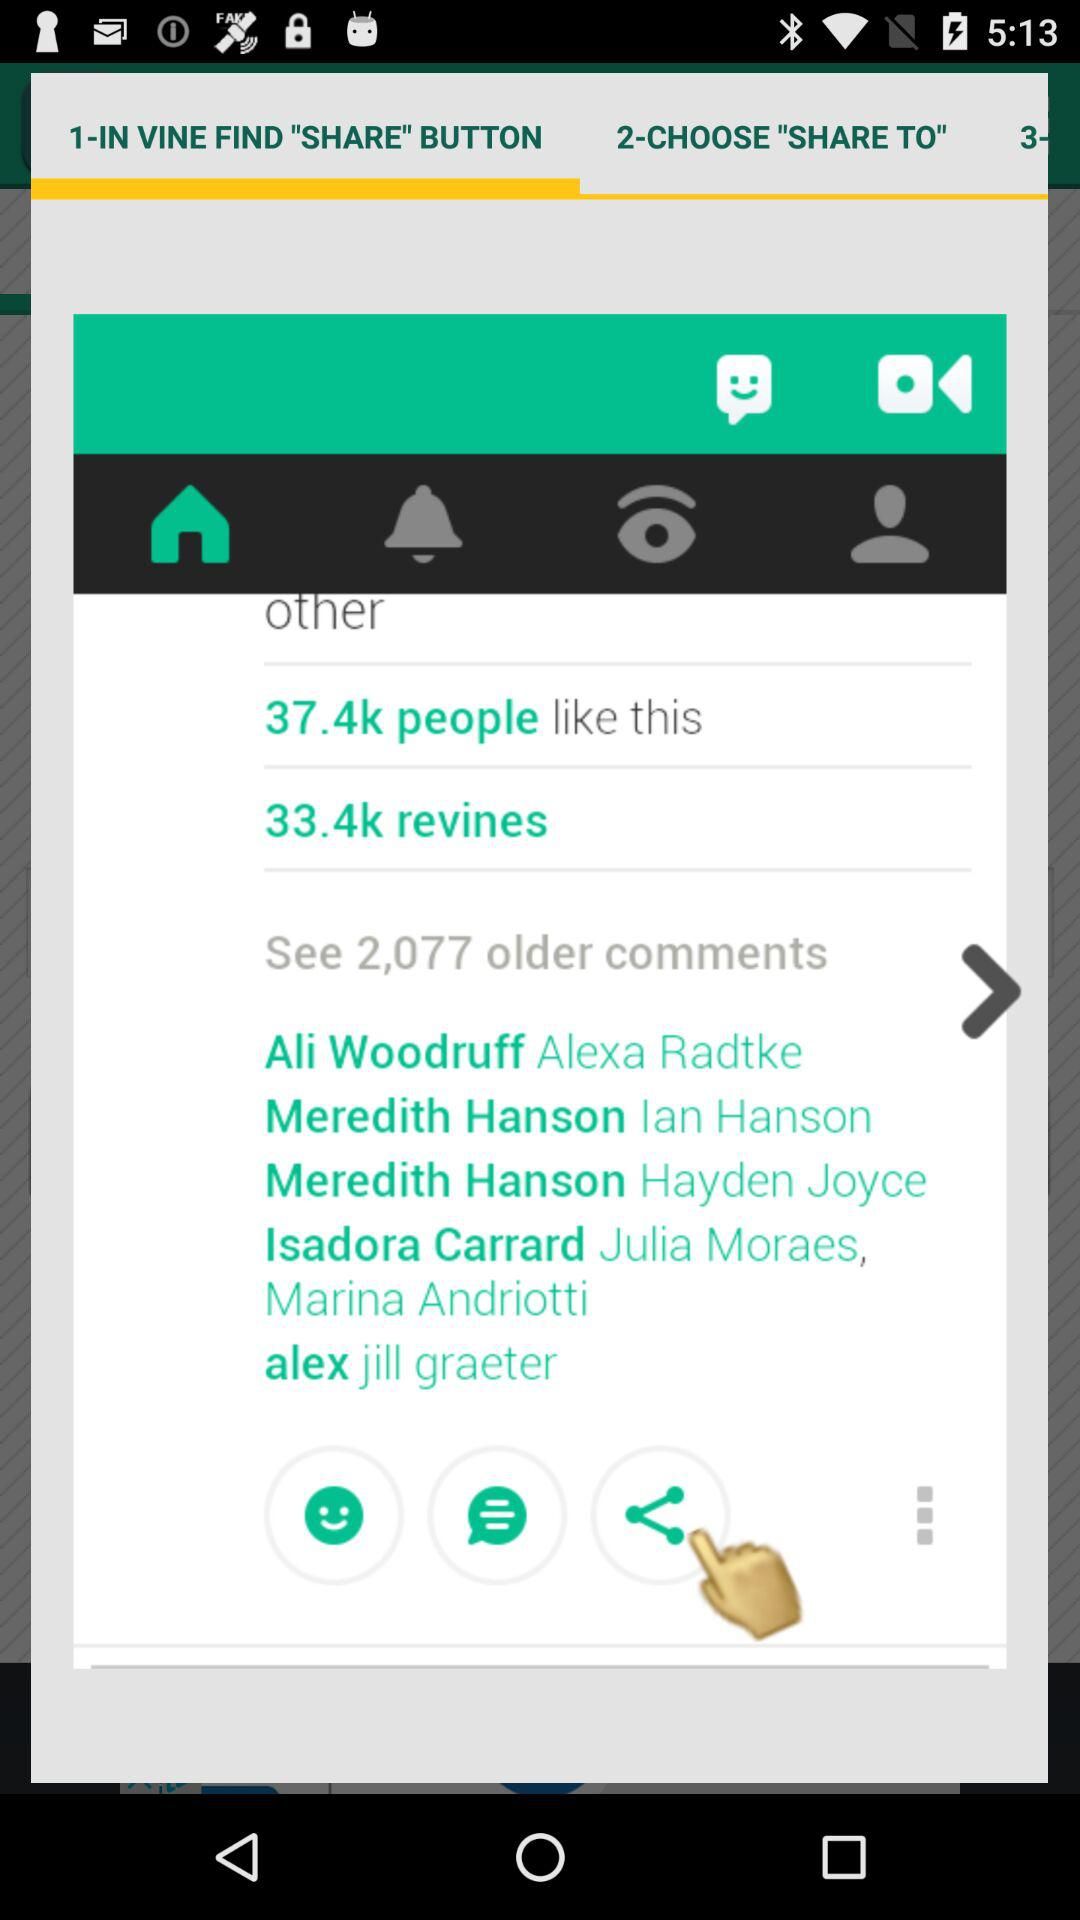How many revines are there? There are 33.4k revines. 